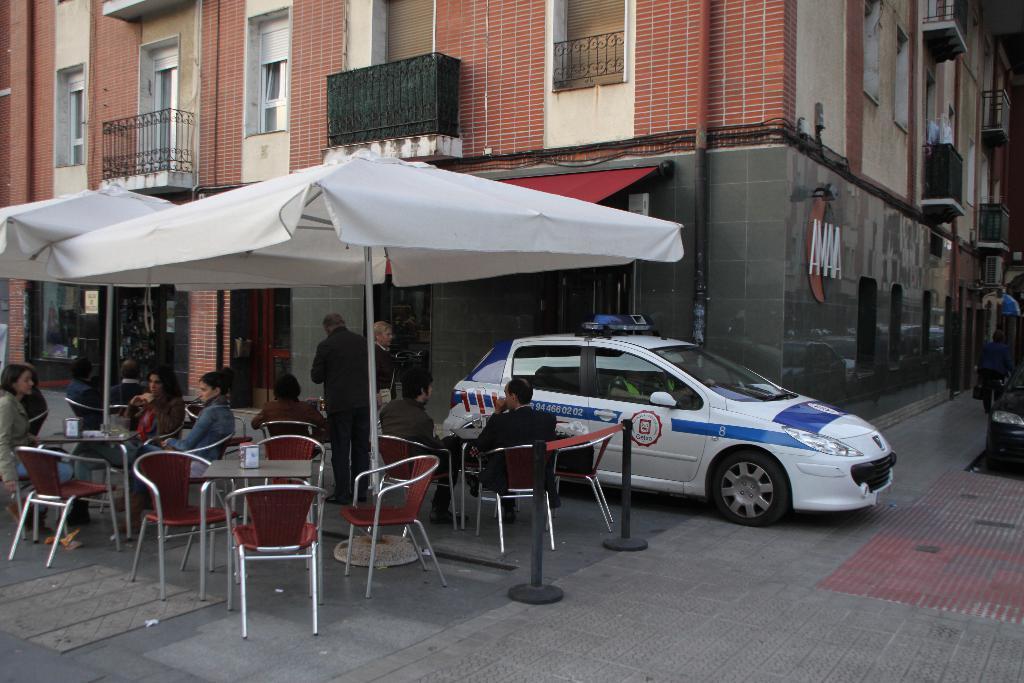Describe this image in one or two sentences. Few people are sitting on the chairs there is an umbrella at here and behind that there is a building. 